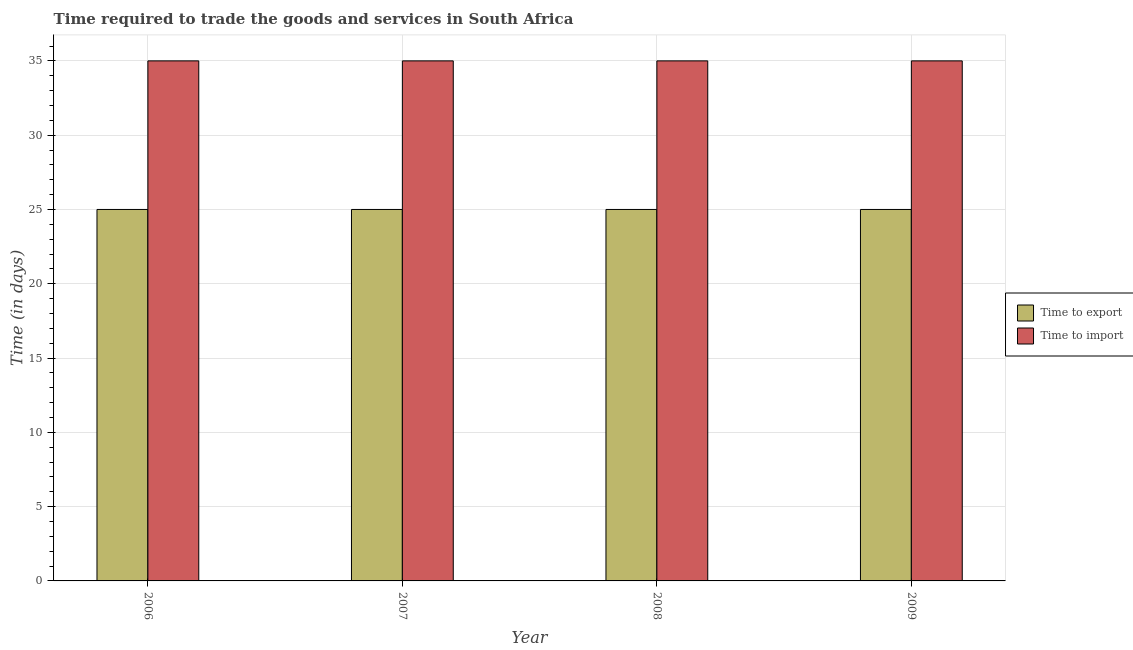How many different coloured bars are there?
Your response must be concise. 2. How many bars are there on the 2nd tick from the left?
Make the answer very short. 2. How many bars are there on the 3rd tick from the right?
Your response must be concise. 2. What is the label of the 3rd group of bars from the left?
Your answer should be very brief. 2008. What is the time to export in 2007?
Your answer should be very brief. 25. Across all years, what is the maximum time to export?
Your answer should be very brief. 25. Across all years, what is the minimum time to export?
Your response must be concise. 25. In which year was the time to export maximum?
Your response must be concise. 2006. What is the total time to import in the graph?
Make the answer very short. 140. What is the difference between the time to export in 2006 and the time to import in 2008?
Your response must be concise. 0. What is the average time to export per year?
Offer a terse response. 25. In the year 2007, what is the difference between the time to export and time to import?
Your response must be concise. 0. In how many years, is the time to import greater than 17 days?
Give a very brief answer. 4. Is the time to import in 2007 less than that in 2008?
Make the answer very short. No. What is the difference between the highest and the second highest time to export?
Offer a very short reply. 0. What is the difference between the highest and the lowest time to export?
Your response must be concise. 0. Is the sum of the time to import in 2006 and 2008 greater than the maximum time to export across all years?
Your answer should be very brief. Yes. What does the 2nd bar from the left in 2009 represents?
Offer a terse response. Time to import. What does the 2nd bar from the right in 2006 represents?
Offer a terse response. Time to export. How many years are there in the graph?
Keep it short and to the point. 4. What is the difference between two consecutive major ticks on the Y-axis?
Your response must be concise. 5. How are the legend labels stacked?
Offer a terse response. Vertical. What is the title of the graph?
Your answer should be very brief. Time required to trade the goods and services in South Africa. What is the label or title of the X-axis?
Your answer should be compact. Year. What is the label or title of the Y-axis?
Make the answer very short. Time (in days). What is the Time (in days) of Time to export in 2007?
Keep it short and to the point. 25. What is the Time (in days) of Time to import in 2007?
Provide a succinct answer. 35. What is the Time (in days) of Time to import in 2008?
Your answer should be compact. 35. What is the Time (in days) of Time to export in 2009?
Your answer should be very brief. 25. Across all years, what is the minimum Time (in days) of Time to import?
Provide a short and direct response. 35. What is the total Time (in days) of Time to import in the graph?
Your answer should be compact. 140. What is the difference between the Time (in days) in Time to export in 2006 and that in 2008?
Offer a very short reply. 0. What is the difference between the Time (in days) in Time to import in 2006 and that in 2008?
Keep it short and to the point. 0. What is the difference between the Time (in days) in Time to export in 2006 and that in 2009?
Your response must be concise. 0. What is the difference between the Time (in days) of Time to import in 2007 and that in 2008?
Your answer should be compact. 0. What is the difference between the Time (in days) of Time to export in 2007 and that in 2009?
Provide a short and direct response. 0. What is the difference between the Time (in days) of Time to import in 2007 and that in 2009?
Make the answer very short. 0. What is the difference between the Time (in days) of Time to export in 2008 and that in 2009?
Keep it short and to the point. 0. What is the difference between the Time (in days) in Time to import in 2008 and that in 2009?
Your answer should be compact. 0. What is the difference between the Time (in days) of Time to export in 2006 and the Time (in days) of Time to import in 2008?
Keep it short and to the point. -10. What is the difference between the Time (in days) of Time to export in 2007 and the Time (in days) of Time to import in 2008?
Provide a short and direct response. -10. What is the difference between the Time (in days) in Time to export in 2008 and the Time (in days) in Time to import in 2009?
Your response must be concise. -10. What is the average Time (in days) of Time to export per year?
Provide a succinct answer. 25. In the year 2006, what is the difference between the Time (in days) of Time to export and Time (in days) of Time to import?
Your answer should be compact. -10. In the year 2007, what is the difference between the Time (in days) of Time to export and Time (in days) of Time to import?
Offer a terse response. -10. In the year 2008, what is the difference between the Time (in days) of Time to export and Time (in days) of Time to import?
Offer a very short reply. -10. What is the ratio of the Time (in days) of Time to import in 2006 to that in 2007?
Provide a succinct answer. 1. What is the ratio of the Time (in days) of Time to export in 2006 to that in 2008?
Your response must be concise. 1. What is the ratio of the Time (in days) in Time to import in 2006 to that in 2009?
Your answer should be compact. 1. What is the ratio of the Time (in days) of Time to export in 2007 to that in 2008?
Your response must be concise. 1. What is the ratio of the Time (in days) in Time to import in 2008 to that in 2009?
Offer a very short reply. 1. What is the difference between the highest and the lowest Time (in days) in Time to export?
Make the answer very short. 0. 